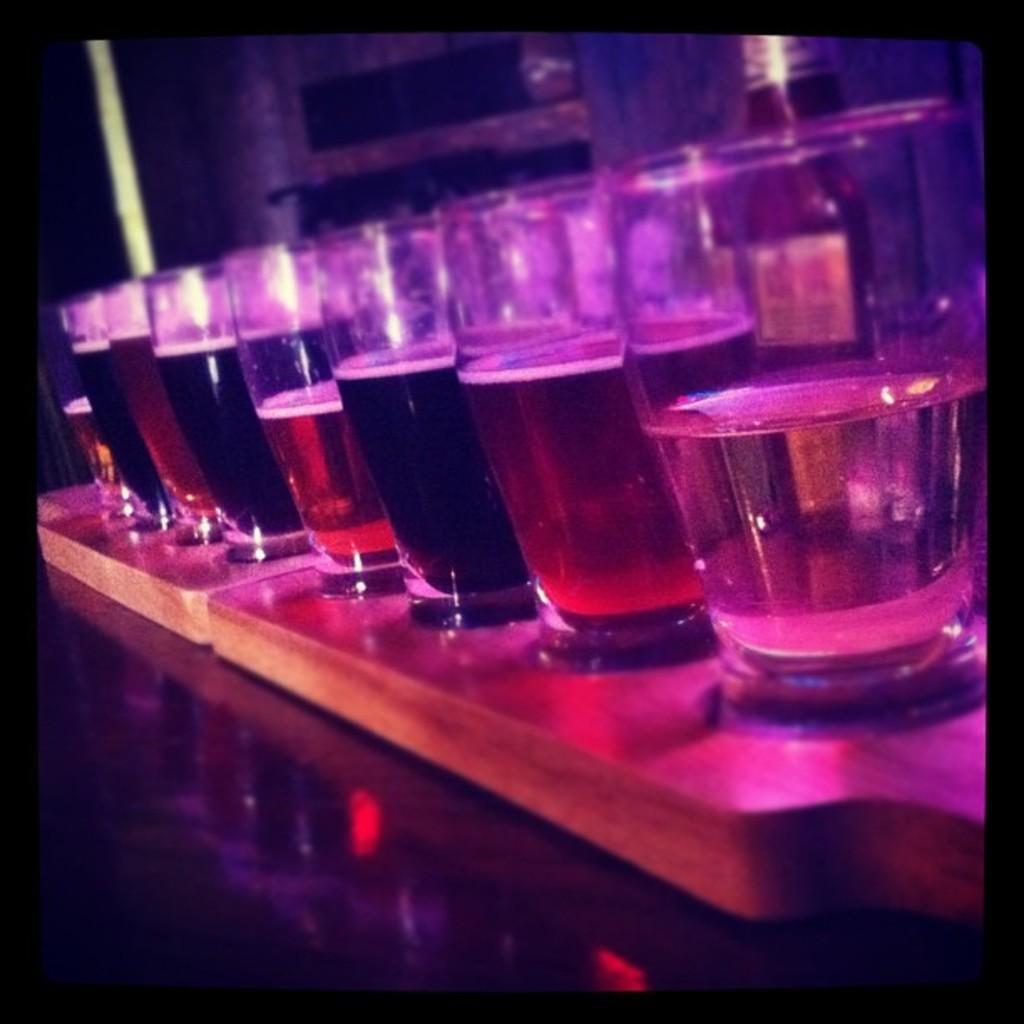Could you give a brief overview of what you see in this image? In this image I can see a brown colored board on the black colored surface and on the board I can see few glasses in which there are liquids which are black and red in color. In the background I can see a bottle. 